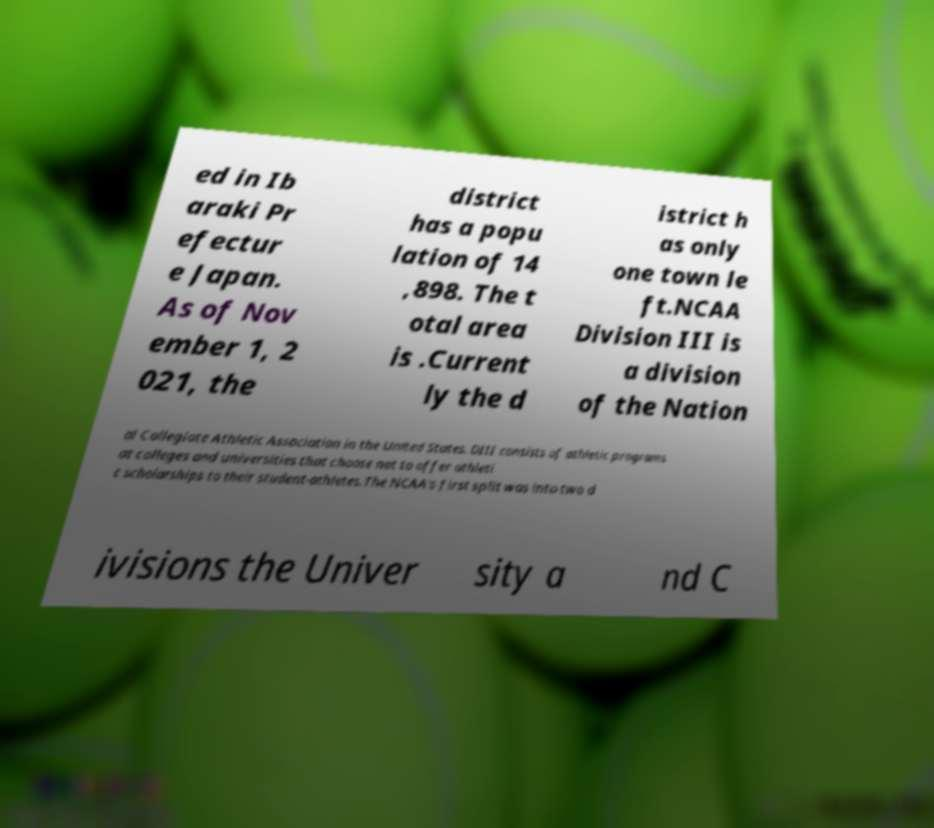Please read and relay the text visible in this image. What does it say? ed in Ib araki Pr efectur e Japan. As of Nov ember 1, 2 021, the district has a popu lation of 14 ,898. The t otal area is .Current ly the d istrict h as only one town le ft.NCAA Division III is a division of the Nation al Collegiate Athletic Association in the United States. DIII consists of athletic programs at colleges and universities that choose not to offer athleti c scholarships to their student-athletes.The NCAA's first split was into two d ivisions the Univer sity a nd C 